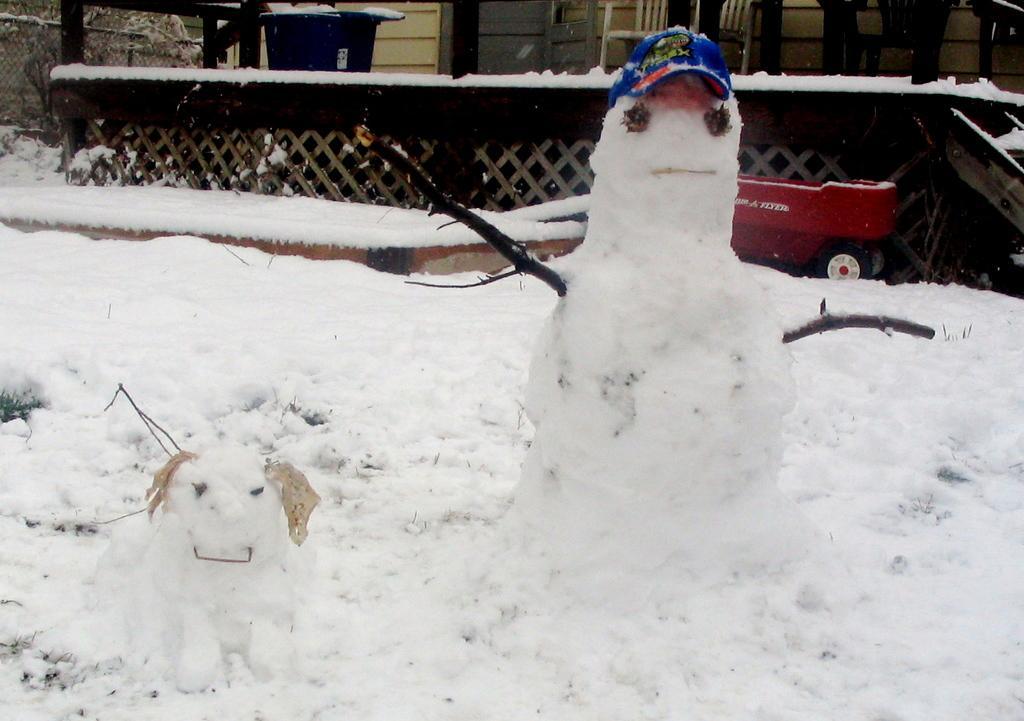In one or two sentences, can you explain what this image depicts? In this picture there is a snow man and a snow dog in the foreground area of the image, it seems to be there is a toy vehicle in the background area of the image and there is a wooden house in the background area of the image, there is snow in the image. 